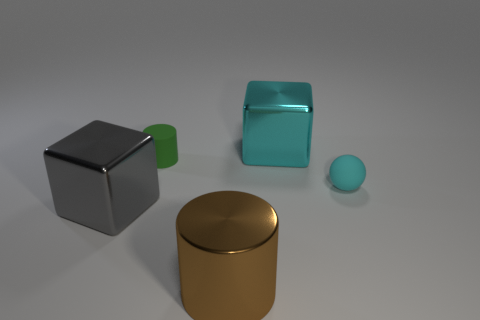What number of big things have the same color as the big cylinder?
Make the answer very short. 0. Are there fewer large cyan shiny blocks that are in front of the green thing than cylinders that are to the right of the small cyan matte sphere?
Provide a short and direct response. No. There is a gray metallic cube; how many big blocks are on the right side of it?
Offer a very short reply. 1. Are there any brown cylinders made of the same material as the big brown object?
Give a very brief answer. No. Are there more green objects right of the tiny cyan matte sphere than green objects that are behind the tiny green object?
Offer a very short reply. No. The rubber cylinder has what size?
Provide a short and direct response. Small. The object that is in front of the big gray metal block has what shape?
Give a very brief answer. Cylinder. Is the green matte thing the same shape as the gray metallic object?
Provide a short and direct response. No. Are there the same number of large cylinders in front of the large brown metallic object and large cyan metal things?
Offer a very short reply. No. What shape is the green thing?
Ensure brevity in your answer.  Cylinder. 